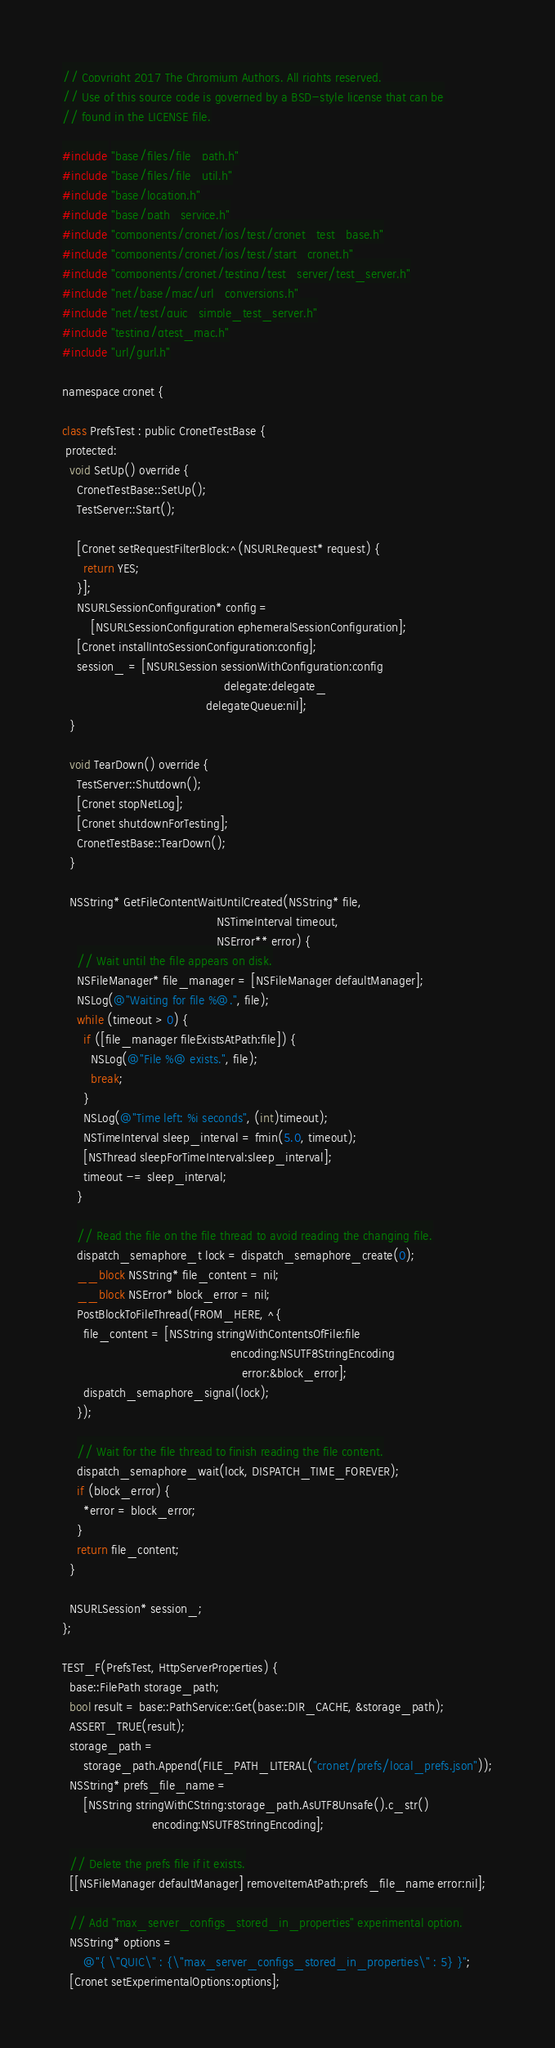<code> <loc_0><loc_0><loc_500><loc_500><_ObjectiveC_>// Copyright 2017 The Chromium Authors. All rights reserved.
// Use of this source code is governed by a BSD-style license that can be
// found in the LICENSE file.

#include "base/files/file_path.h"
#include "base/files/file_util.h"
#include "base/location.h"
#include "base/path_service.h"
#include "components/cronet/ios/test/cronet_test_base.h"
#include "components/cronet/ios/test/start_cronet.h"
#include "components/cronet/testing/test_server/test_server.h"
#include "net/base/mac/url_conversions.h"
#include "net/test/quic_simple_test_server.h"
#include "testing/gtest_mac.h"
#include "url/gurl.h"

namespace cronet {

class PrefsTest : public CronetTestBase {
 protected:
  void SetUp() override {
    CronetTestBase::SetUp();
    TestServer::Start();

    [Cronet setRequestFilterBlock:^(NSURLRequest* request) {
      return YES;
    }];
    NSURLSessionConfiguration* config =
        [NSURLSessionConfiguration ephemeralSessionConfiguration];
    [Cronet installIntoSessionConfiguration:config];
    session_ = [NSURLSession sessionWithConfiguration:config
                                             delegate:delegate_
                                        delegateQueue:nil];
  }

  void TearDown() override {
    TestServer::Shutdown();
    [Cronet stopNetLog];
    [Cronet shutdownForTesting];
    CronetTestBase::TearDown();
  }

  NSString* GetFileContentWaitUntilCreated(NSString* file,
                                           NSTimeInterval timeout,
                                           NSError** error) {
    // Wait until the file appears on disk.
    NSFileManager* file_manager = [NSFileManager defaultManager];
    NSLog(@"Waiting for file %@.", file);
    while (timeout > 0) {
      if ([file_manager fileExistsAtPath:file]) {
        NSLog(@"File %@ exists.", file);
        break;
      }
      NSLog(@"Time left: %i seconds", (int)timeout);
      NSTimeInterval sleep_interval = fmin(5.0, timeout);
      [NSThread sleepForTimeInterval:sleep_interval];
      timeout -= sleep_interval;
    }

    // Read the file on the file thread to avoid reading the changing file.
    dispatch_semaphore_t lock = dispatch_semaphore_create(0);
    __block NSString* file_content = nil;
    __block NSError* block_error = nil;
    PostBlockToFileThread(FROM_HERE, ^{
      file_content = [NSString stringWithContentsOfFile:file
                                               encoding:NSUTF8StringEncoding
                                                  error:&block_error];
      dispatch_semaphore_signal(lock);
    });

    // Wait for the file thread to finish reading the file content.
    dispatch_semaphore_wait(lock, DISPATCH_TIME_FOREVER);
    if (block_error) {
      *error = block_error;
    }
    return file_content;
  }

  NSURLSession* session_;
};

TEST_F(PrefsTest, HttpServerProperties) {
  base::FilePath storage_path;
  bool result = base::PathService::Get(base::DIR_CACHE, &storage_path);
  ASSERT_TRUE(result);
  storage_path =
      storage_path.Append(FILE_PATH_LITERAL("cronet/prefs/local_prefs.json"));
  NSString* prefs_file_name =
      [NSString stringWithCString:storage_path.AsUTF8Unsafe().c_str()
                         encoding:NSUTF8StringEncoding];

  // Delete the prefs file if it exists.
  [[NSFileManager defaultManager] removeItemAtPath:prefs_file_name error:nil];

  // Add "max_server_configs_stored_in_properties" experimental option.
  NSString* options =
      @"{ \"QUIC\" : {\"max_server_configs_stored_in_properties\" : 5} }";
  [Cronet setExperimentalOptions:options];
</code> 